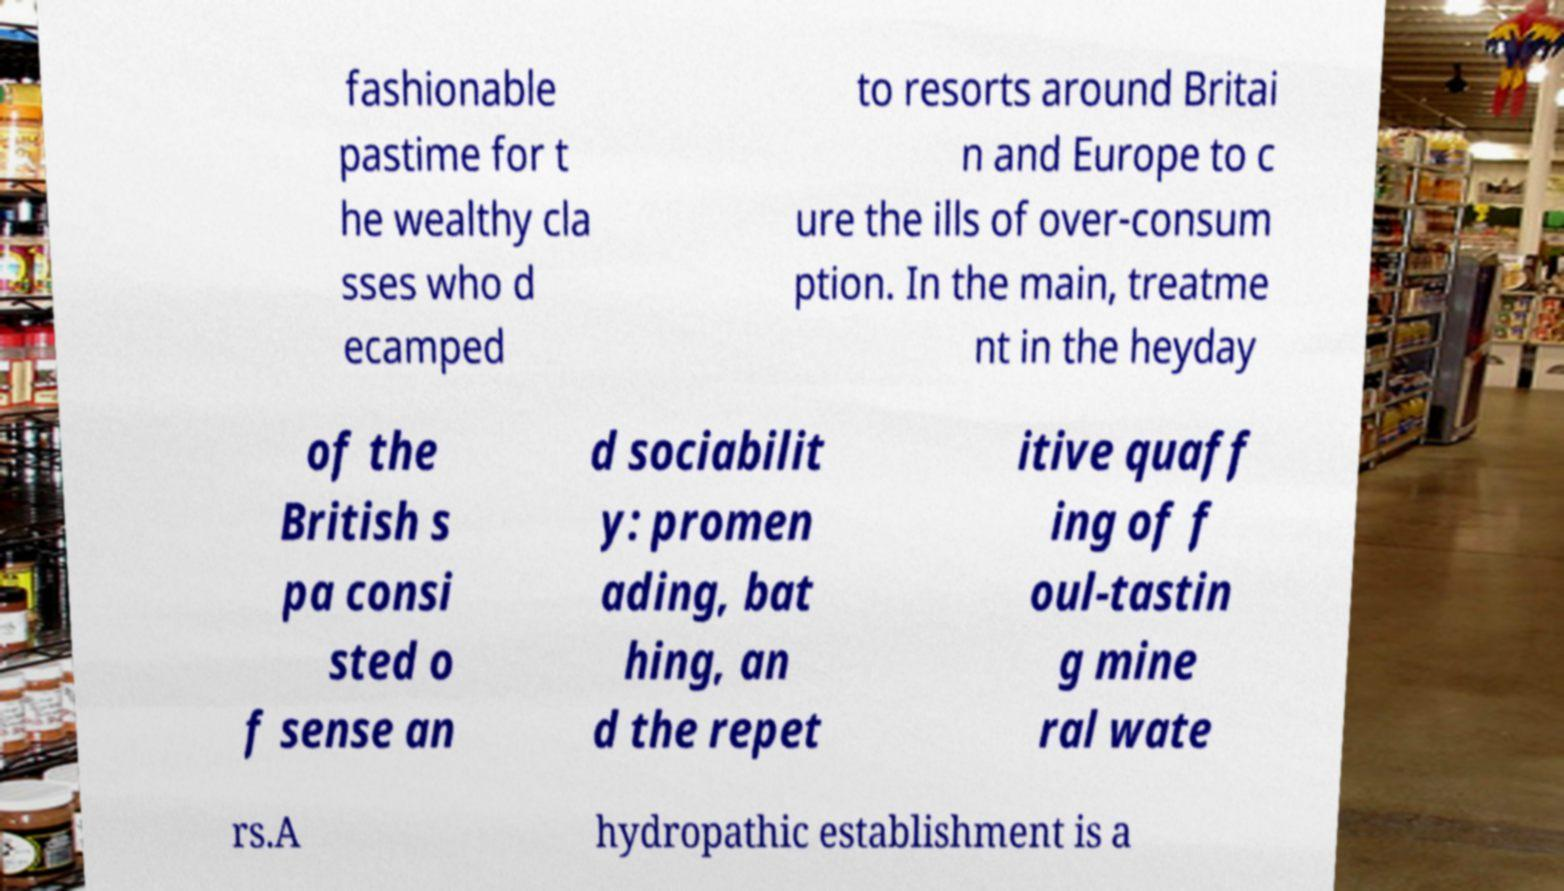Could you extract and type out the text from this image? fashionable pastime for t he wealthy cla sses who d ecamped to resorts around Britai n and Europe to c ure the ills of over-consum ption. In the main, treatme nt in the heyday of the British s pa consi sted o f sense an d sociabilit y: promen ading, bat hing, an d the repet itive quaff ing of f oul-tastin g mine ral wate rs.A hydropathic establishment is a 